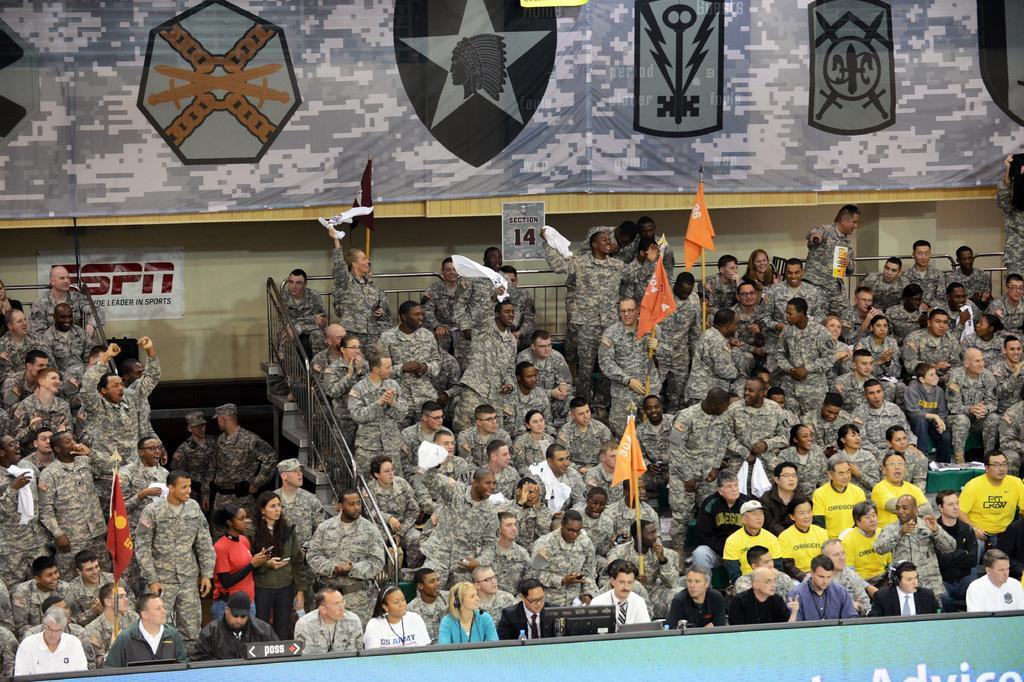Describe this image in one or two sentences. In this image we can see group of persons most of them wearing camouflage dress sitting and some are standing and we can see some flags and in the background of the image there is a wall and some sheets. 